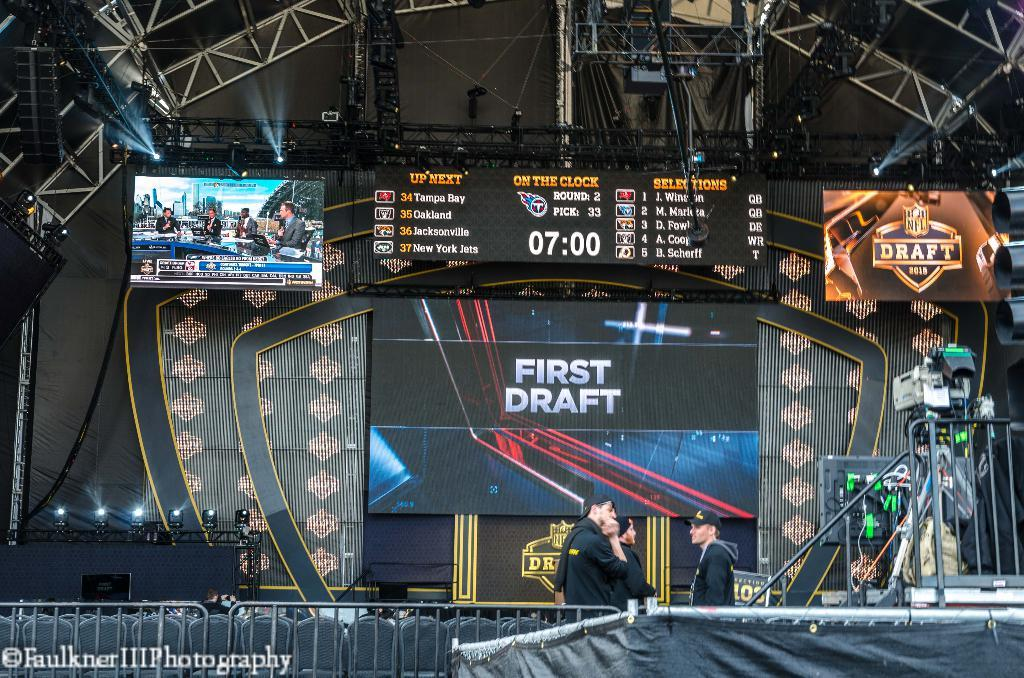<image>
Share a concise interpretation of the image provided. A stage for a fotball game with the words first draft in the center. 